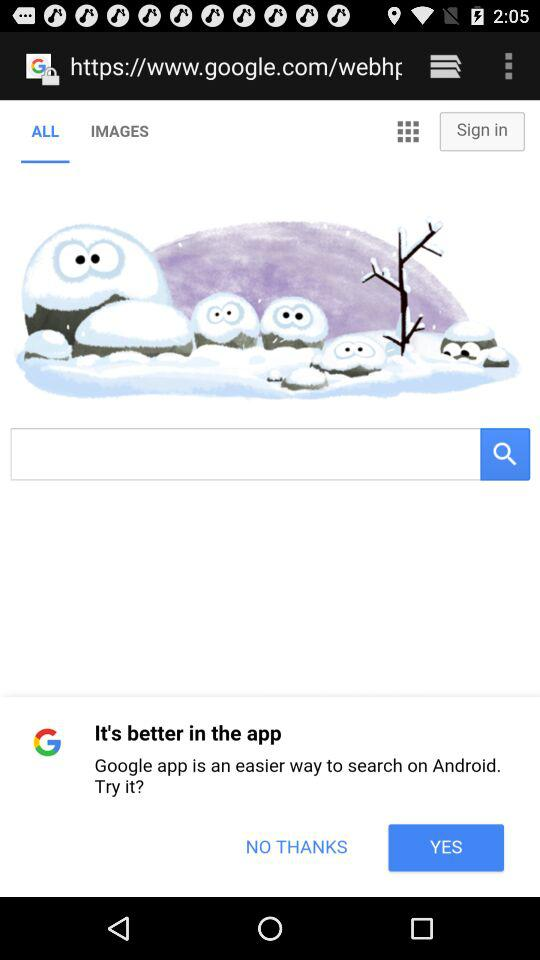Which tab is selected? The selected tab is "ALL". 